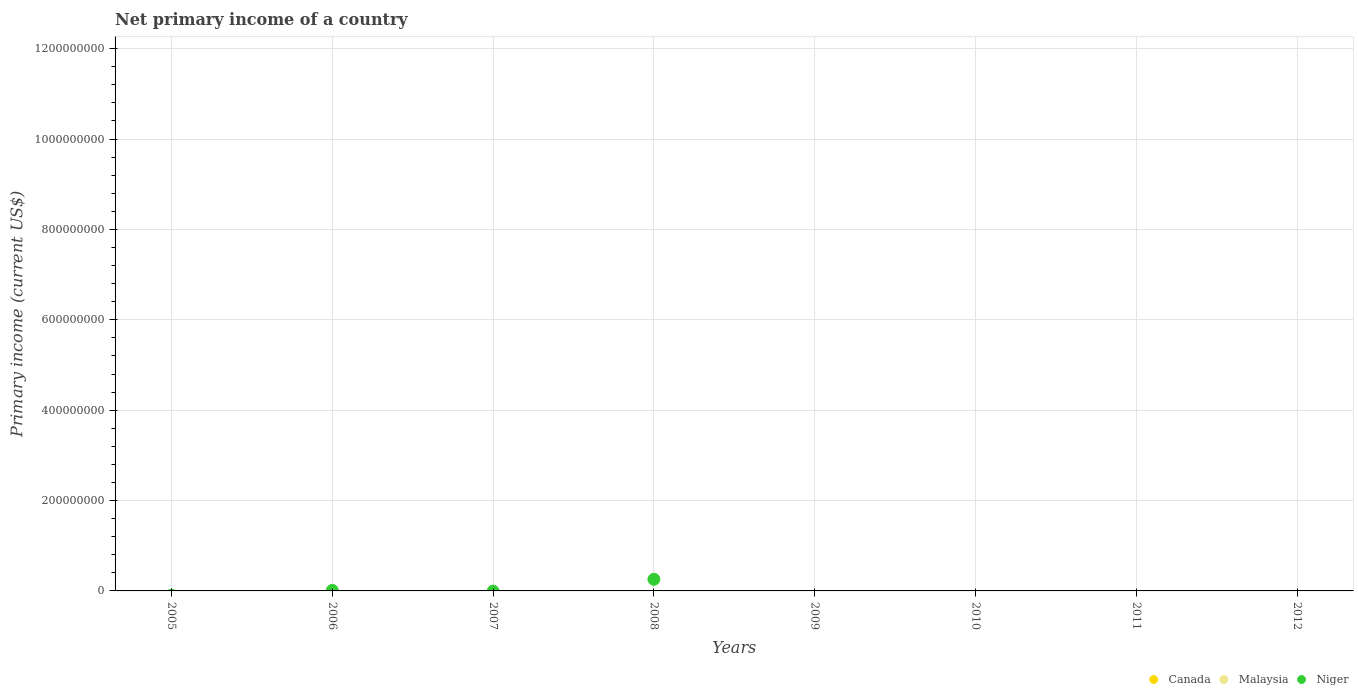Is the number of dotlines equal to the number of legend labels?
Provide a short and direct response. No. Across all years, what is the maximum primary income in Niger?
Provide a short and direct response. 2.57e+07. Across all years, what is the minimum primary income in Niger?
Ensure brevity in your answer.  0. In which year was the primary income in Niger maximum?
Offer a very short reply. 2008. What is the difference between the primary income in Niger in 2006 and that in 2008?
Your answer should be compact. -2.45e+07. What is the difference between the primary income in Niger in 2005 and the primary income in Canada in 2008?
Keep it short and to the point. 0. What is the average primary income in Niger per year?
Your answer should be compact. 3.37e+06. In how many years, is the primary income in Canada greater than 320000000 US$?
Provide a succinct answer. 0. What is the difference between the highest and the lowest primary income in Niger?
Provide a short and direct response. 2.57e+07. Is it the case that in every year, the sum of the primary income in Malaysia and primary income in Canada  is greater than the primary income in Niger?
Give a very brief answer. No. How many dotlines are there?
Offer a very short reply. 1. How many years are there in the graph?
Ensure brevity in your answer.  8. Where does the legend appear in the graph?
Your response must be concise. Bottom right. How many legend labels are there?
Ensure brevity in your answer.  3. How are the legend labels stacked?
Make the answer very short. Horizontal. What is the title of the graph?
Ensure brevity in your answer.  Net primary income of a country. Does "Cambodia" appear as one of the legend labels in the graph?
Your answer should be very brief. No. What is the label or title of the X-axis?
Offer a very short reply. Years. What is the label or title of the Y-axis?
Provide a succinct answer. Primary income (current US$). What is the Primary income (current US$) in Niger in 2005?
Ensure brevity in your answer.  0. What is the Primary income (current US$) in Canada in 2006?
Your answer should be very brief. 0. What is the Primary income (current US$) of Niger in 2006?
Offer a very short reply. 1.21e+06. What is the Primary income (current US$) of Canada in 2007?
Make the answer very short. 0. What is the Primary income (current US$) in Niger in 2007?
Offer a terse response. 0. What is the Primary income (current US$) of Canada in 2008?
Offer a terse response. 0. What is the Primary income (current US$) in Niger in 2008?
Offer a terse response. 2.57e+07. What is the Primary income (current US$) of Canada in 2009?
Offer a very short reply. 0. What is the Primary income (current US$) of Canada in 2010?
Ensure brevity in your answer.  0. What is the Primary income (current US$) of Malaysia in 2010?
Provide a short and direct response. 0. What is the Primary income (current US$) of Niger in 2010?
Give a very brief answer. 0. What is the Primary income (current US$) in Niger in 2011?
Provide a succinct answer. 0. Across all years, what is the maximum Primary income (current US$) of Niger?
Give a very brief answer. 2.57e+07. What is the total Primary income (current US$) in Canada in the graph?
Your answer should be very brief. 0. What is the total Primary income (current US$) in Malaysia in the graph?
Make the answer very short. 0. What is the total Primary income (current US$) in Niger in the graph?
Provide a succinct answer. 2.69e+07. What is the difference between the Primary income (current US$) in Niger in 2006 and that in 2008?
Provide a succinct answer. -2.45e+07. What is the average Primary income (current US$) in Canada per year?
Offer a terse response. 0. What is the average Primary income (current US$) in Malaysia per year?
Make the answer very short. 0. What is the average Primary income (current US$) of Niger per year?
Provide a short and direct response. 3.37e+06. What is the ratio of the Primary income (current US$) of Niger in 2006 to that in 2008?
Your answer should be compact. 0.05. What is the difference between the highest and the lowest Primary income (current US$) of Niger?
Ensure brevity in your answer.  2.57e+07. 